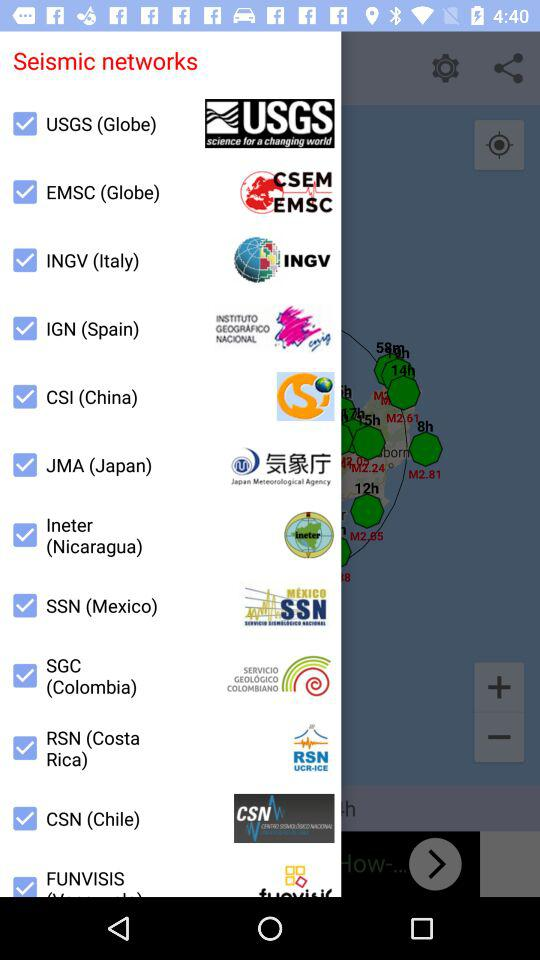What is the seismic network of Japan? The seismic network of Japan is JMA. 